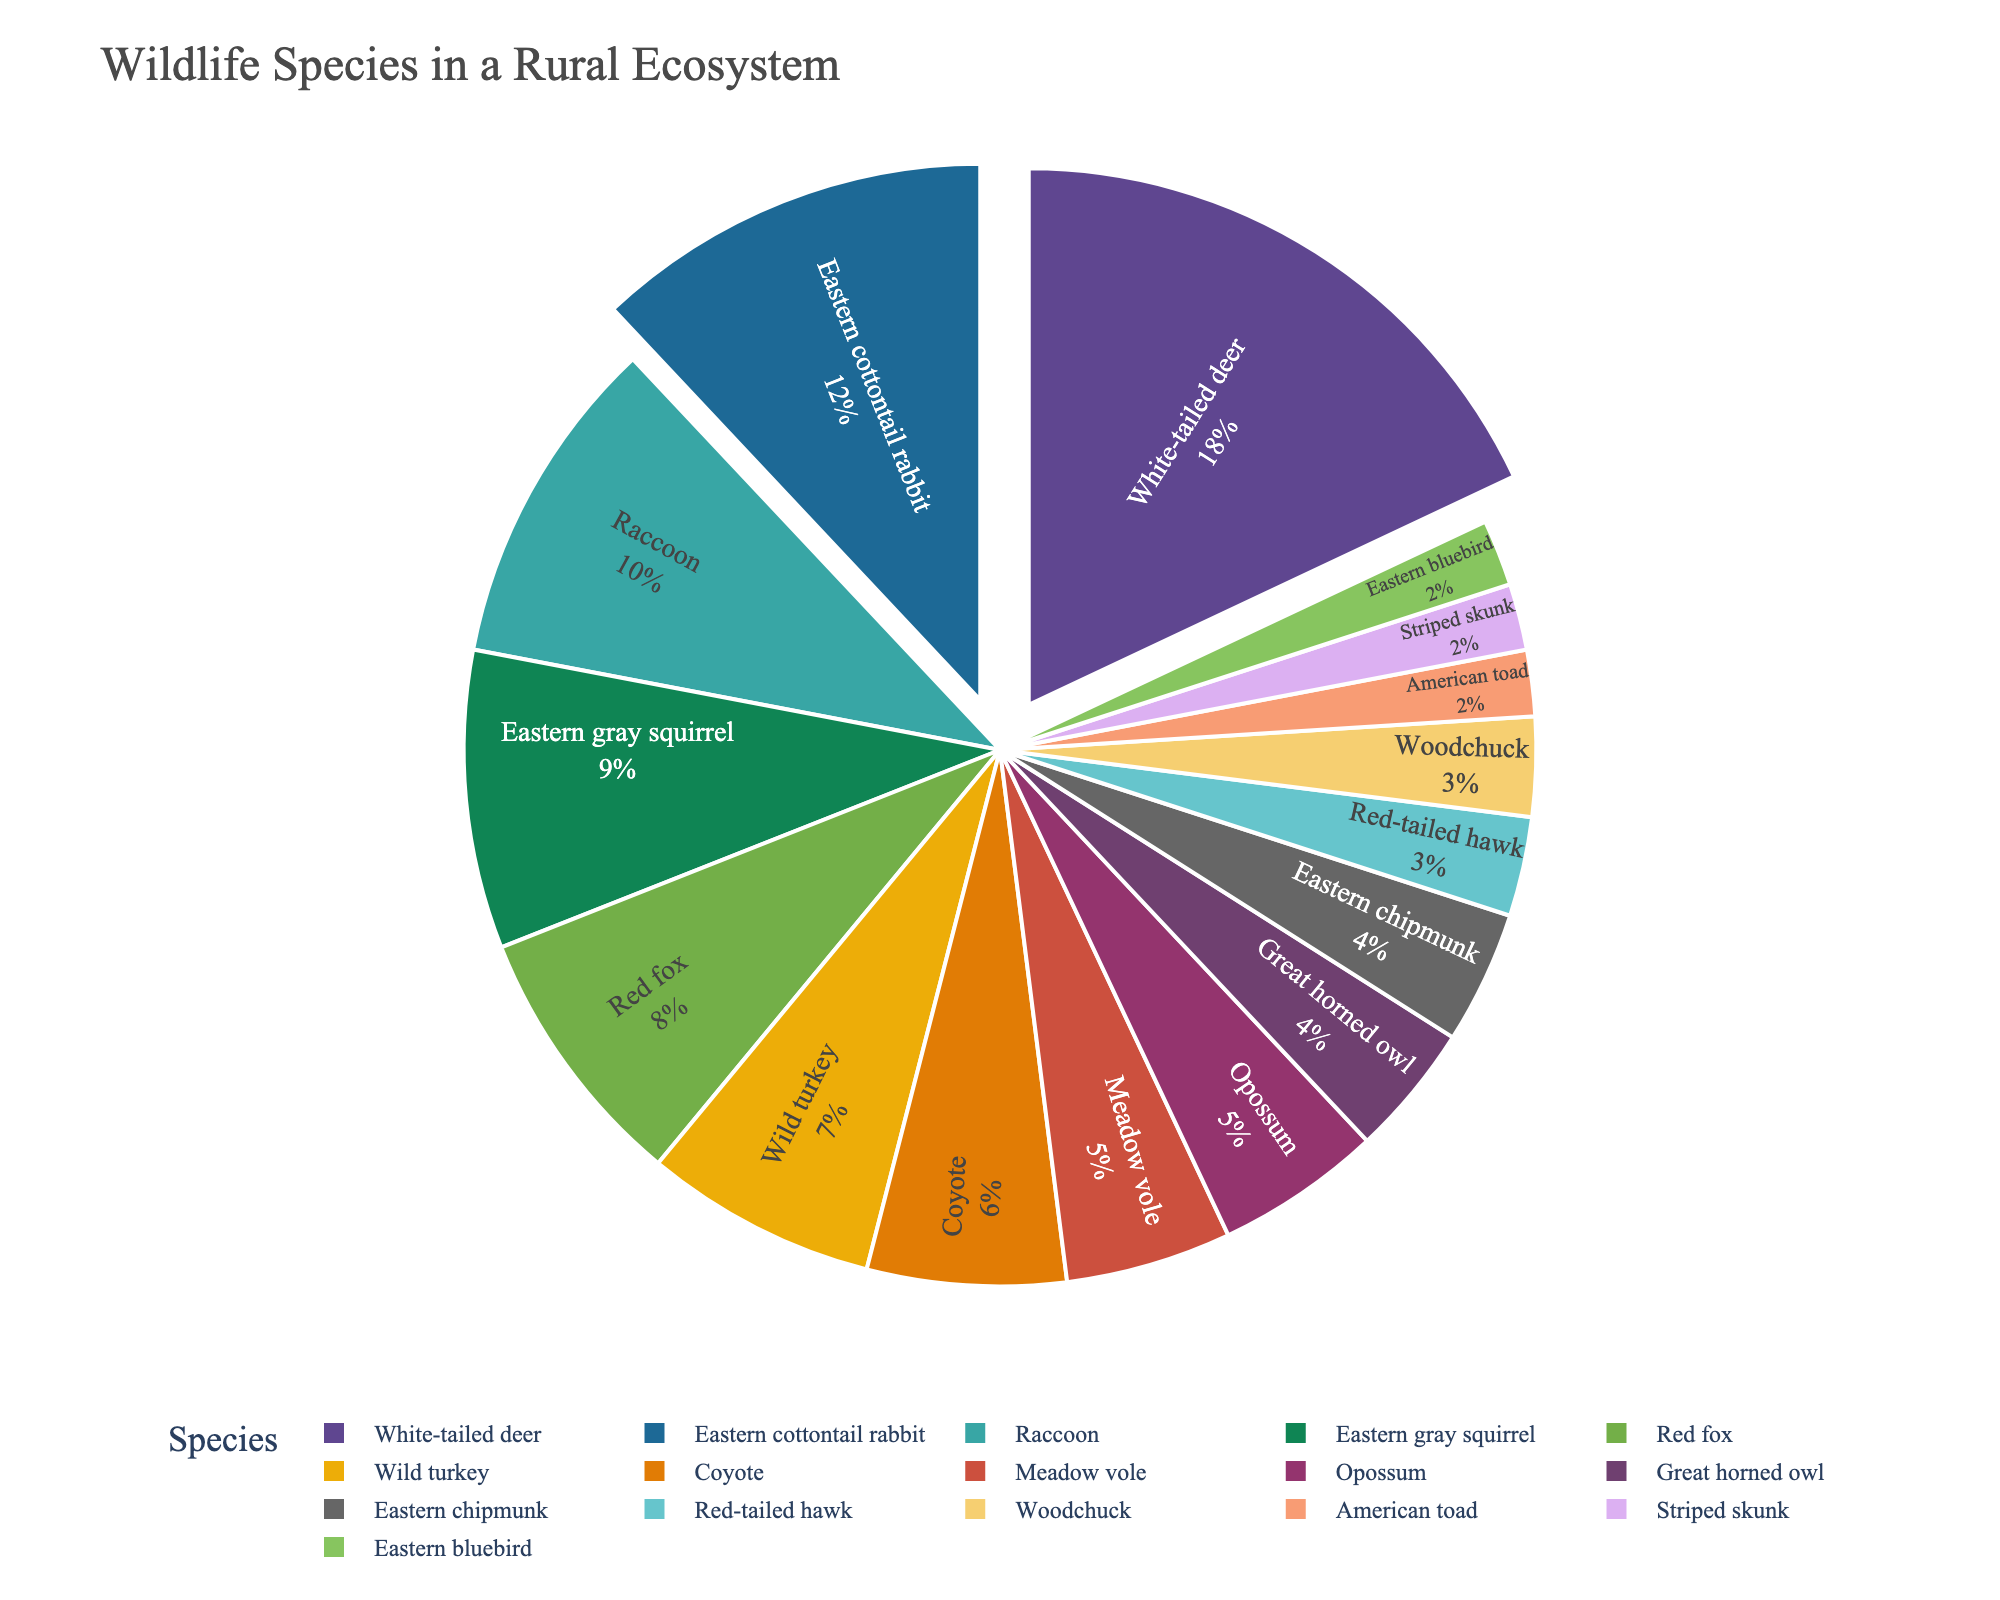What species has the highest proportion in the rural ecosystem? To determine the species with the highest proportion, refer to the pie chart and identify the segment that represents the largest percentage. The largest segment is labeled "White-tailed deer".
Answer: White-tailed deer Which species constitutes exactly 4% of the ecosystem? Examine the segments of the pie chart to find the one labeled with 4%. The segments labeled with 4% are “Great horned owl” and “Eastern chipmunk”.
Answer: Great horned owl, Eastern chipmunk How much greater is the proportion of Eastern cottontail rabbit than the American toad? The proportion of the Eastern cottontail rabbit is 12%, and the proportion of the American toad is 2%. Calculate the difference: 12% - 2% = 10%.
Answer: 10% Which species have a proportional share less than 5%? Look at the pie chart and identify all segments representing less than 5%. The segments are labeled "Great horned owl", "Red-tailed hawk", "Meadow vole", "Eastern chipmunk", "Woodchuck", "American toad", "Striped skunk", and “Eastern bluebird”.
Answer: Great horned owl, Red-tailed hawk, Meadow vole, Eastern chipmunk, Woodchuck, American toad, Striped skunk, Eastern bluebird Is the proportion of Red foxes equal to the proportion of Eastern gray squirrels? Compare the percentage labels of Red fox and Eastern gray squirrel in the pie chart. Red foxes constitute 8%, and Eastern gray squirrels make up 9%. Since 8% ≠ 9%, they are not equal.
Answer: No What is the combined proportion of raccoons and wild turkeys? Sum the percentages of “Raccoon” and “Wild turkey” by adding 10% and 7%. Thus, the total combined proportion is 10% + 7% = 17%.
Answer: 17% What color represents the White-tailed deer segment? Reference the color palette used in the pie chart to identify the color associated with the "White-tailed deer" segment. The White-tailed deer is represented by the color used for its segment, which can vary but typically is visually distinct for ease of identification.
Answer: Varies by chart design (check specific color) Which species make up approximately one-third (around 33%) of the ecosystem when combined? Identify species whose combined percentages approximate 33%. The Eastern cottontail rabbit (12%), Raccoon (10%), and Eastern gray squirrel (9%) together add up to 31%, or White-tailed deer (18%) and Eastern cottontail rabbit (12%) together total 30%, but White-tailed deer (18%), Eastern cottontail rabbit (12%), and Red fox (8%) make up 38%, slightly over one-third. The 18% (White-tailed deer), 9% (Eastern gray squirrel), 6% (Coyote) combination total exactly 33%.
Answer: White-tailed deer, Eastern gray squirrel, Coyote 